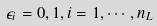<formula> <loc_0><loc_0><loc_500><loc_500>\epsilon _ { i } = 0 , 1 , i = 1 , \cdots , n _ { L }</formula> 